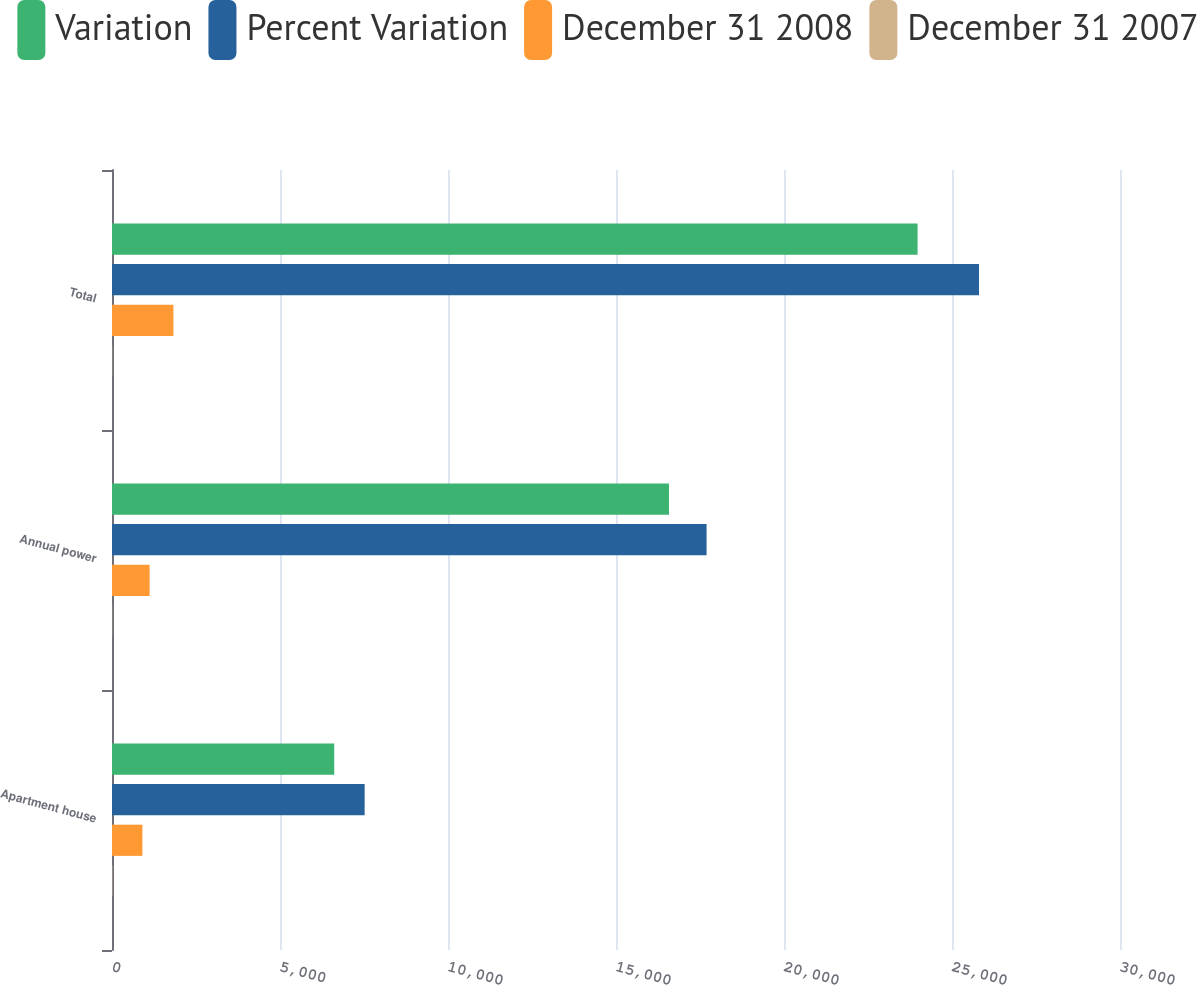Convert chart to OTSL. <chart><loc_0><loc_0><loc_500><loc_500><stacked_bar_chart><ecel><fcel>Apartment house<fcel>Annual power<fcel>Total<nl><fcel>Variation<fcel>6614<fcel>16577<fcel>23976<nl><fcel>Percent Variation<fcel>7519<fcel>17696<fcel>25804<nl><fcel>December 31 2008<fcel>905<fcel>1119<fcel>1828<nl><fcel>December 31 2007<fcel>12<fcel>6.3<fcel>7.1<nl></chart> 